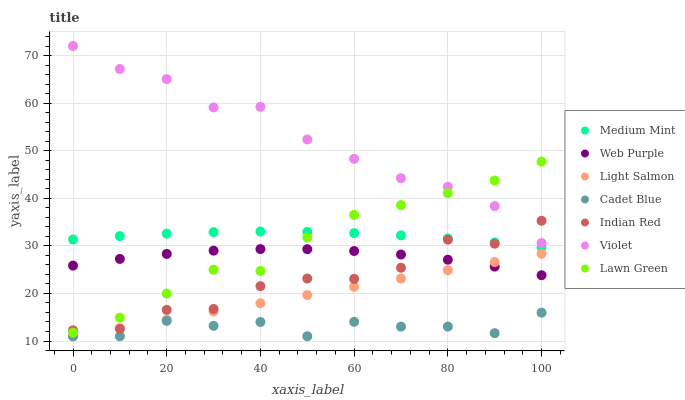Does Cadet Blue have the minimum area under the curve?
Answer yes or no. Yes. Does Violet have the maximum area under the curve?
Answer yes or no. Yes. Does Lawn Green have the minimum area under the curve?
Answer yes or no. No. Does Lawn Green have the maximum area under the curve?
Answer yes or no. No. Is Light Salmon the smoothest?
Answer yes or no. Yes. Is Indian Red the roughest?
Answer yes or no. Yes. Is Lawn Green the smoothest?
Answer yes or no. No. Is Lawn Green the roughest?
Answer yes or no. No. Does Light Salmon have the lowest value?
Answer yes or no. Yes. Does Lawn Green have the lowest value?
Answer yes or no. No. Does Violet have the highest value?
Answer yes or no. Yes. Does Lawn Green have the highest value?
Answer yes or no. No. Is Light Salmon less than Lawn Green?
Answer yes or no. Yes. Is Lawn Green greater than Light Salmon?
Answer yes or no. Yes. Does Indian Red intersect Lawn Green?
Answer yes or no. Yes. Is Indian Red less than Lawn Green?
Answer yes or no. No. Is Indian Red greater than Lawn Green?
Answer yes or no. No. Does Light Salmon intersect Lawn Green?
Answer yes or no. No. 